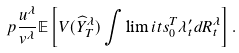<formula> <loc_0><loc_0><loc_500><loc_500>p \frac { u ^ { \lambda } } { v ^ { \lambda } } \mathbb { E } \left [ V ( \widehat { Y } ^ { \lambda } _ { T } ) \int \lim i t s _ { 0 } ^ { T } { \lambda _ { t } ^ { \prime } d R ^ { \lambda } _ { t } } \right ] .</formula> 